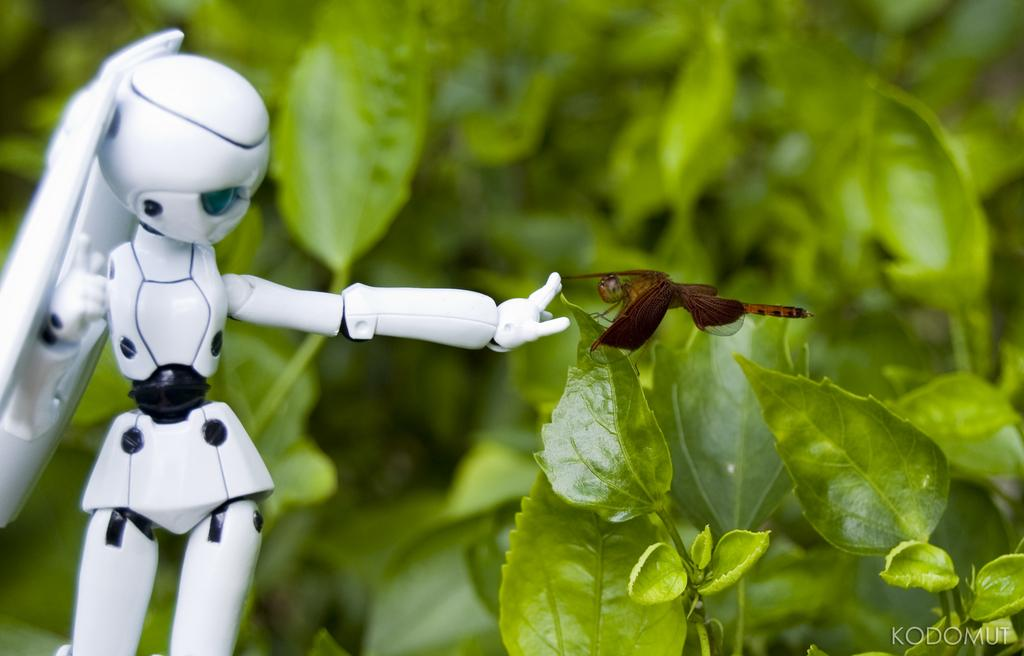What type of animal can be seen on a tree in the image? There is an insect on a tree in the image. What other subject can be seen in the image? There is a robot in the image. What type of representative is present in the image? There is no representative present in the image; it features an insect on a tree and a robot. How many chickens can be seen in the image? There are no chickens present in the image. 